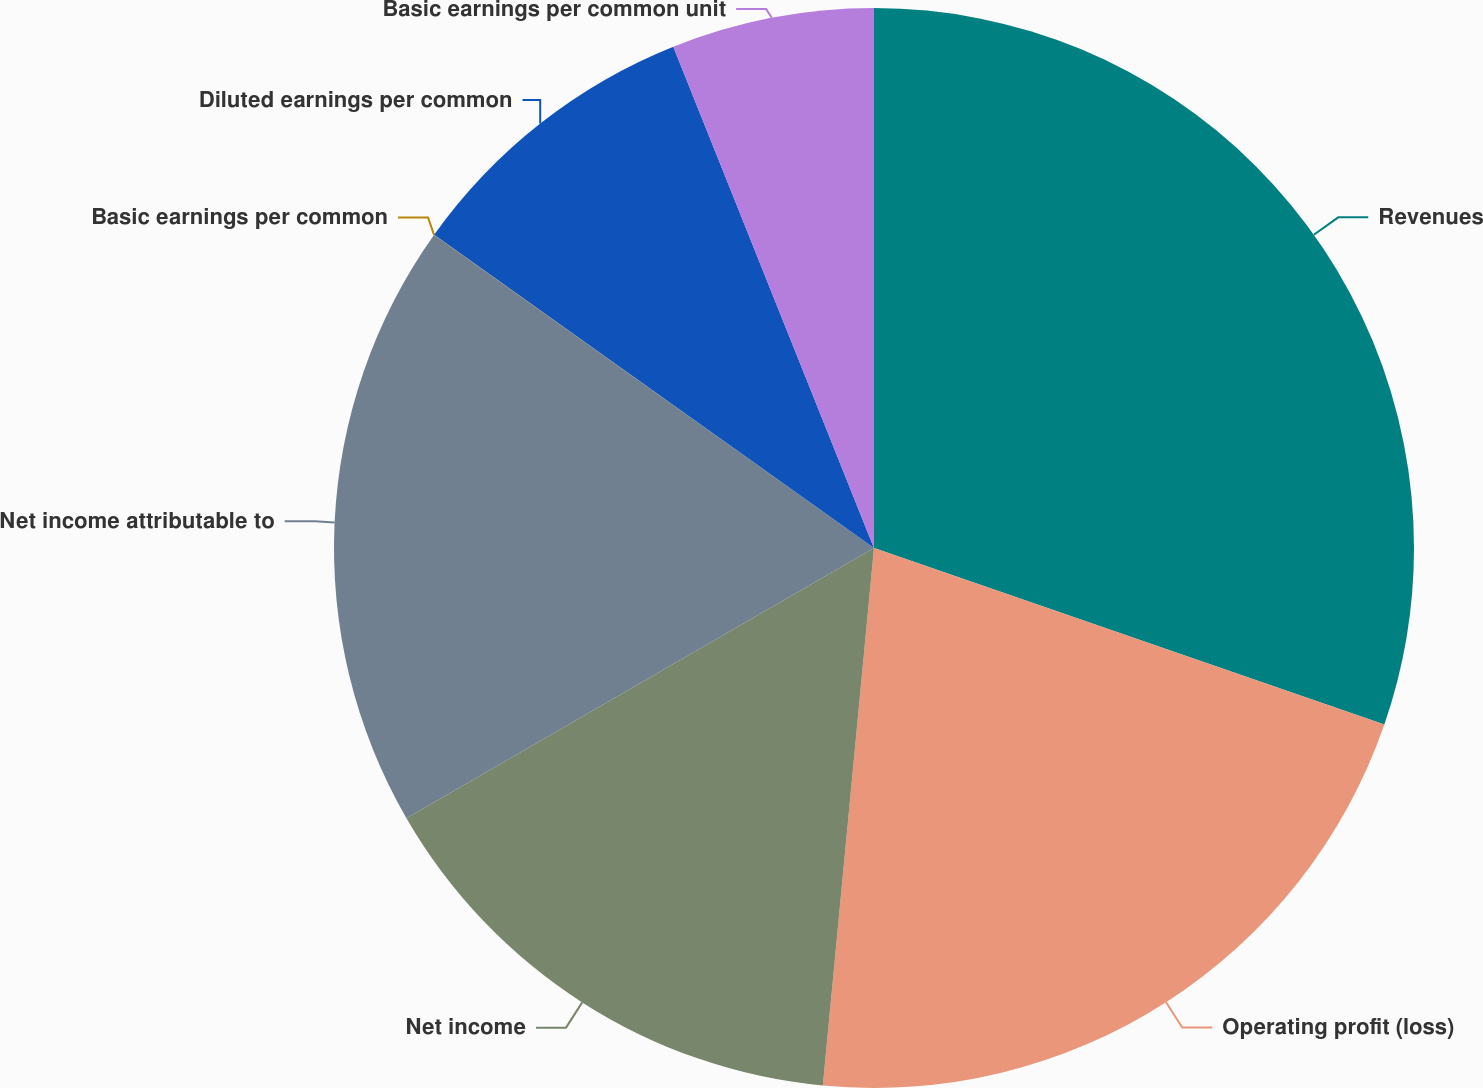Convert chart. <chart><loc_0><loc_0><loc_500><loc_500><pie_chart><fcel>Revenues<fcel>Operating profit (loss)<fcel>Net income<fcel>Net income attributable to<fcel>Basic earnings per common<fcel>Diluted earnings per common<fcel>Basic earnings per common unit<nl><fcel>30.3%<fcel>21.21%<fcel>15.15%<fcel>18.18%<fcel>0.01%<fcel>9.09%<fcel>6.06%<nl></chart> 